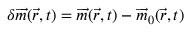<formula> <loc_0><loc_0><loc_500><loc_500>\delta \overrightarrow { m } ( \vec { r } , t ) = \overrightarrow { m } ( \vec { r } , t ) - \overrightarrow { m } _ { 0 } ( \vec { r } , t )</formula> 